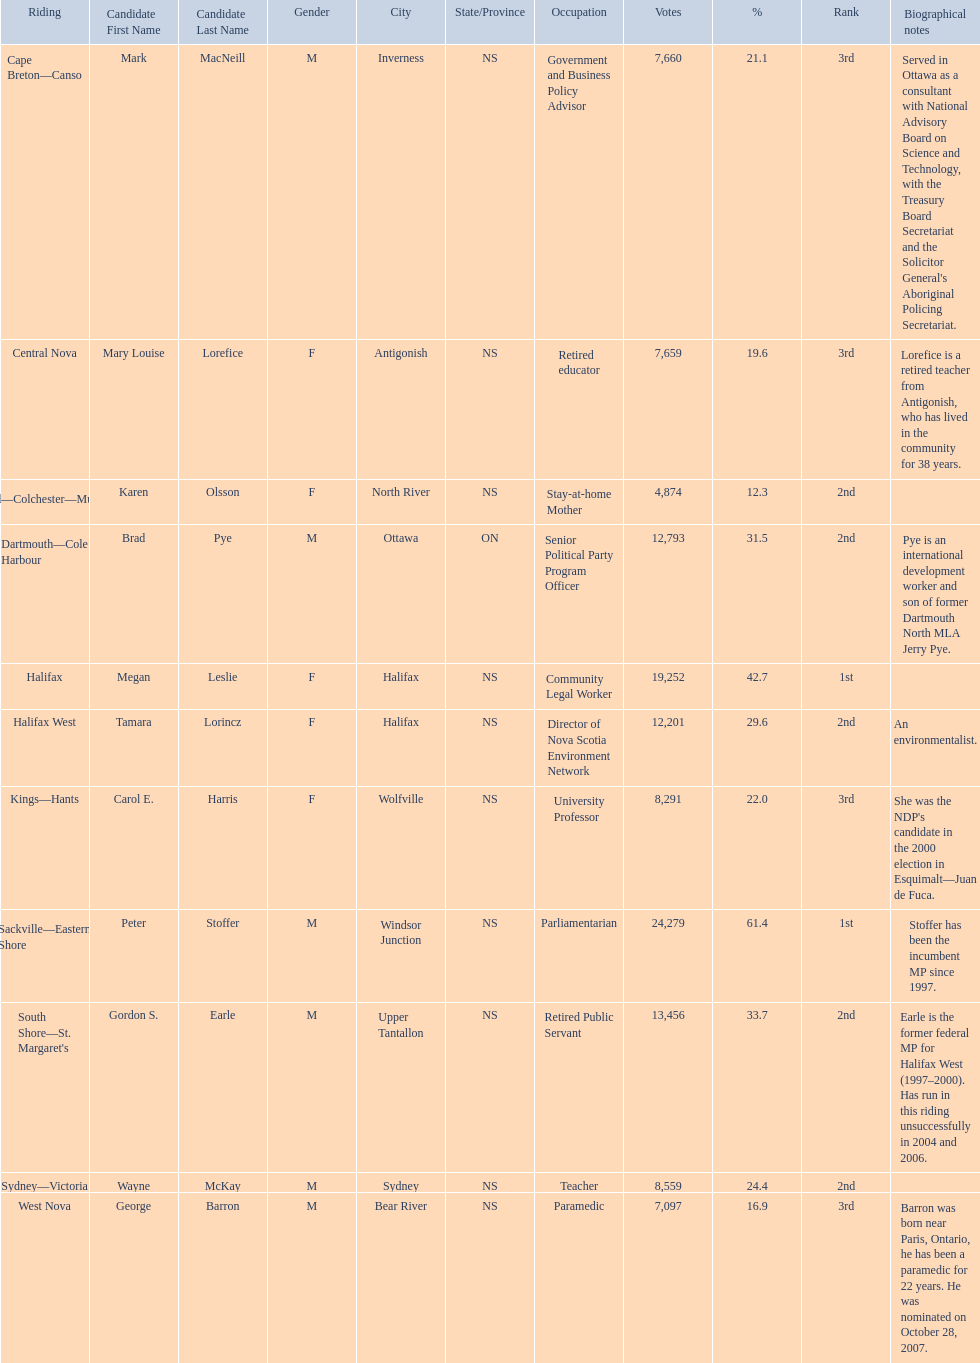Who were all of the new democratic party candidates during the 2008 canadian federal election? Mark MacNeill, Mary Louise Lorefice, Karen Olsson, Brad Pye, Megan Leslie, Tamara Lorincz, Carol E. Harris, Peter Stoffer, Gordon S. Earle, Wayne McKay, George Barron. And between mark macneill and karen olsson, which candidate received more votes? Mark MacNeill. 